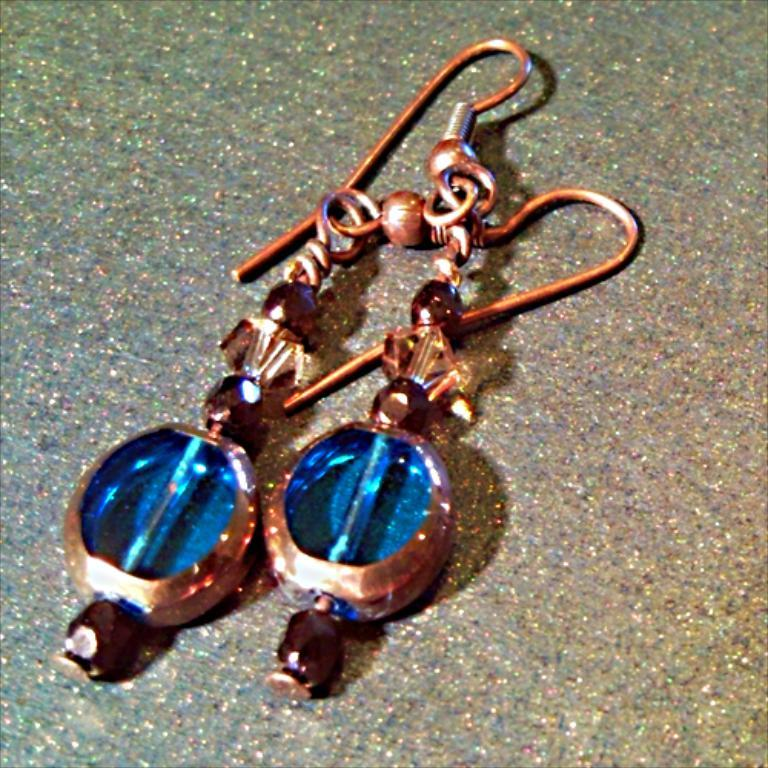What type of accessory is visible in the image? There is a pair of earrings in the image. Where are the earrings located? The earrings are on a surface. How many sisters are playing with the balls under the tree in the image? There are no sisters, balls, or tree present in the image; it only features a pair of earrings on a surface. 